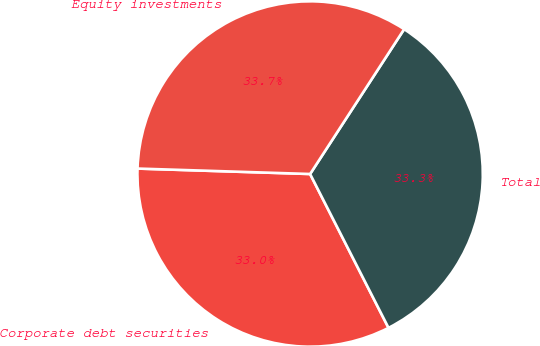<chart> <loc_0><loc_0><loc_500><loc_500><pie_chart><fcel>Corporate debt securities<fcel>Total<fcel>Equity investments<nl><fcel>33.0%<fcel>33.33%<fcel>33.66%<nl></chart> 